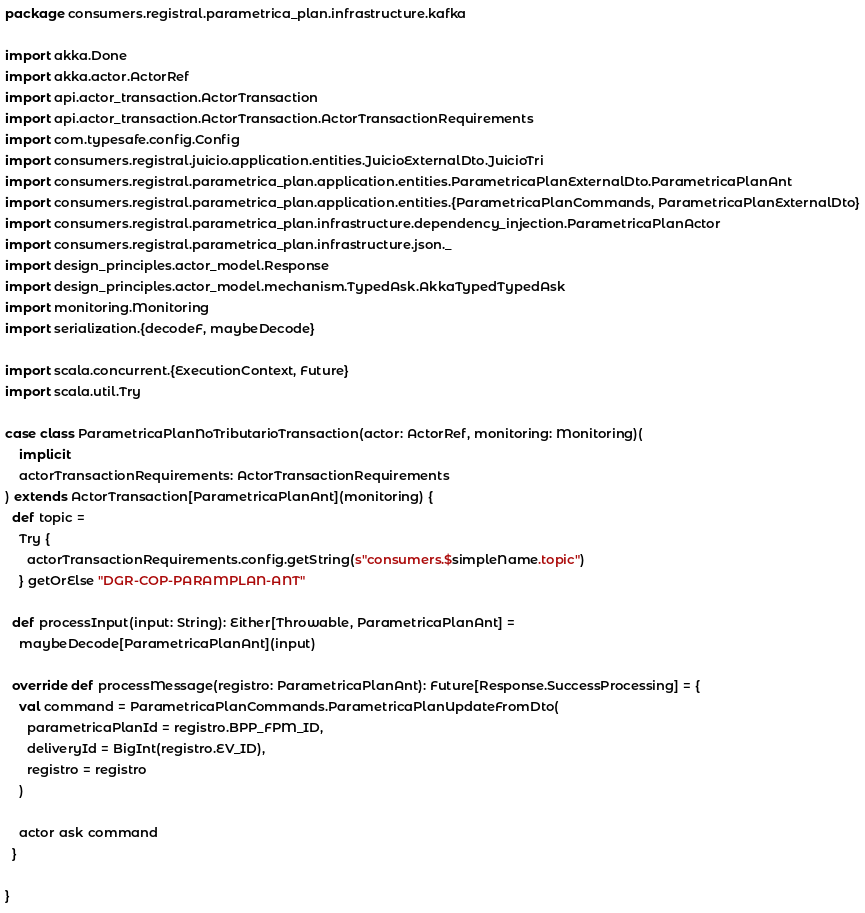Convert code to text. <code><loc_0><loc_0><loc_500><loc_500><_Scala_>package consumers.registral.parametrica_plan.infrastructure.kafka

import akka.Done
import akka.actor.ActorRef
import api.actor_transaction.ActorTransaction
import api.actor_transaction.ActorTransaction.ActorTransactionRequirements
import com.typesafe.config.Config
import consumers.registral.juicio.application.entities.JuicioExternalDto.JuicioTri
import consumers.registral.parametrica_plan.application.entities.ParametricaPlanExternalDto.ParametricaPlanAnt
import consumers.registral.parametrica_plan.application.entities.{ParametricaPlanCommands, ParametricaPlanExternalDto}
import consumers.registral.parametrica_plan.infrastructure.dependency_injection.ParametricaPlanActor
import consumers.registral.parametrica_plan.infrastructure.json._
import design_principles.actor_model.Response
import design_principles.actor_model.mechanism.TypedAsk.AkkaTypedTypedAsk
import monitoring.Monitoring
import serialization.{decodeF, maybeDecode}

import scala.concurrent.{ExecutionContext, Future}
import scala.util.Try

case class ParametricaPlanNoTributarioTransaction(actor: ActorRef, monitoring: Monitoring)(
    implicit
    actorTransactionRequirements: ActorTransactionRequirements
) extends ActorTransaction[ParametricaPlanAnt](monitoring) {
  def topic =
    Try {
      actorTransactionRequirements.config.getString(s"consumers.$simpleName.topic")
    } getOrElse "DGR-COP-PARAMPLAN-ANT"

  def processInput(input: String): Either[Throwable, ParametricaPlanAnt] =
    maybeDecode[ParametricaPlanAnt](input)

  override def processMessage(registro: ParametricaPlanAnt): Future[Response.SuccessProcessing] = {
    val command = ParametricaPlanCommands.ParametricaPlanUpdateFromDto(
      parametricaPlanId = registro.BPP_FPM_ID,
      deliveryId = BigInt(registro.EV_ID),
      registro = registro
    )

    actor ask command
  }

}
</code> 